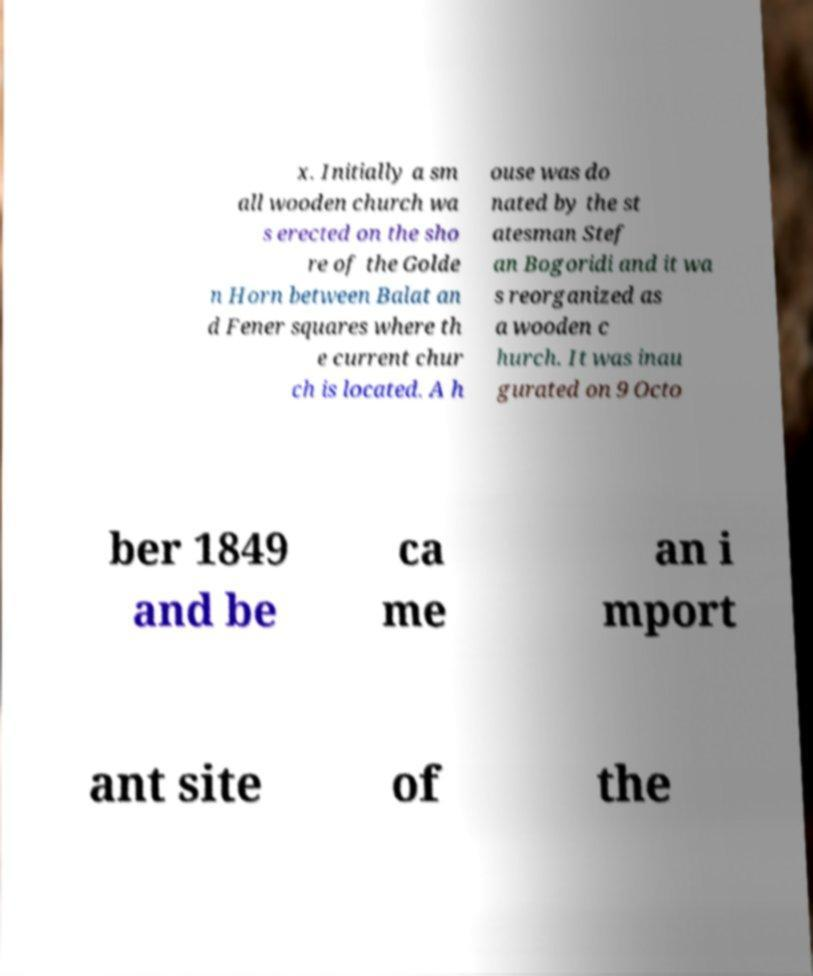Could you extract and type out the text from this image? x. Initially a sm all wooden church wa s erected on the sho re of the Golde n Horn between Balat an d Fener squares where th e current chur ch is located. A h ouse was do nated by the st atesman Stef an Bogoridi and it wa s reorganized as a wooden c hurch. It was inau gurated on 9 Octo ber 1849 and be ca me an i mport ant site of the 